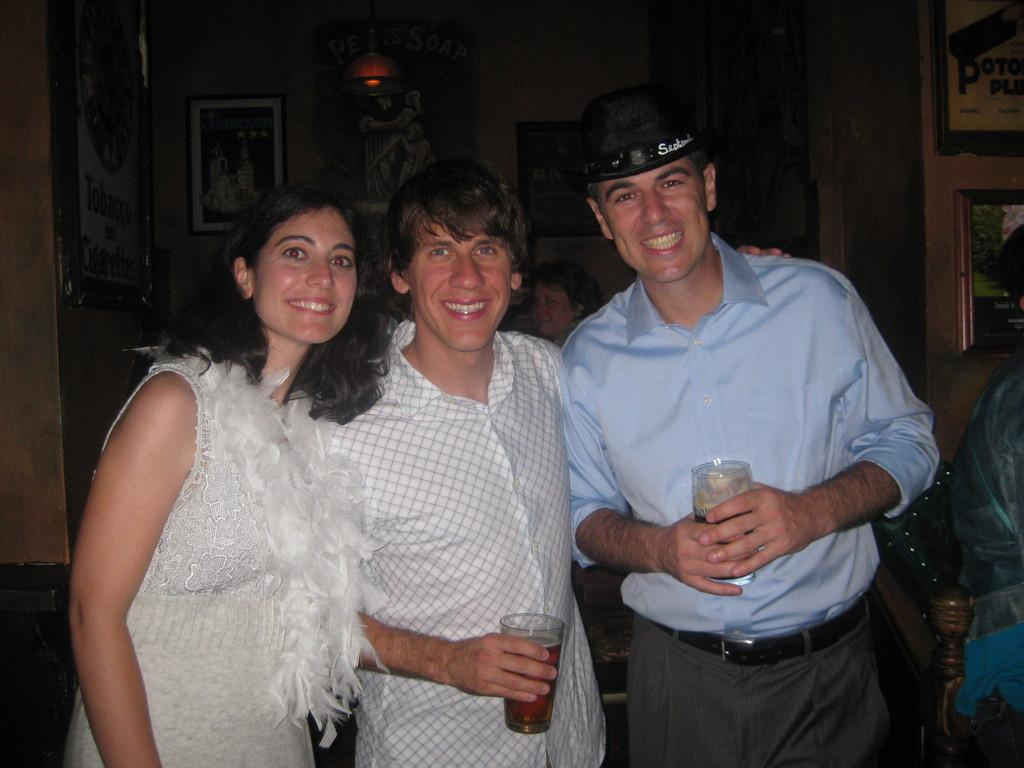How many people are in the image? There are three people in the image. What are the people doing in the image? The people are smiling in the image. What are two of the people holding? Two people are holding glasses in the image. What can be seen in the background of the image? There is a wall, a woman, photo frames, and a light in the background of the image. What type of fear can be seen on the woman's face in the image? There is no fear visible on anyone's face in the image; the people are smiling. What type of office equipment can be seen in the image? There is no office equipment present in the image. 